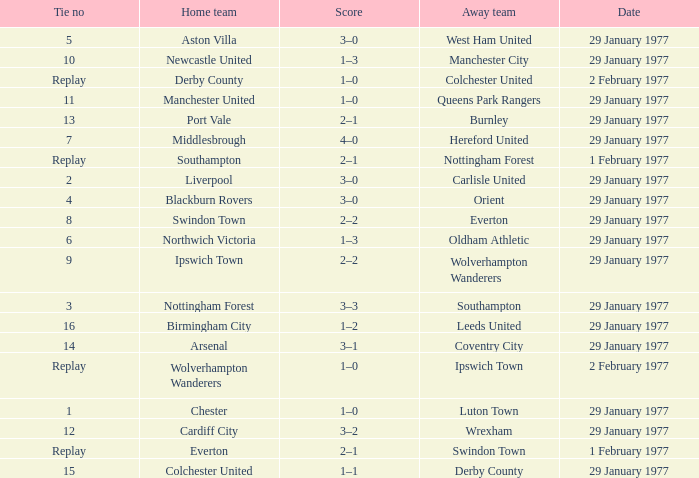What is the tie number when the home team is Port Vale? 13.0. 